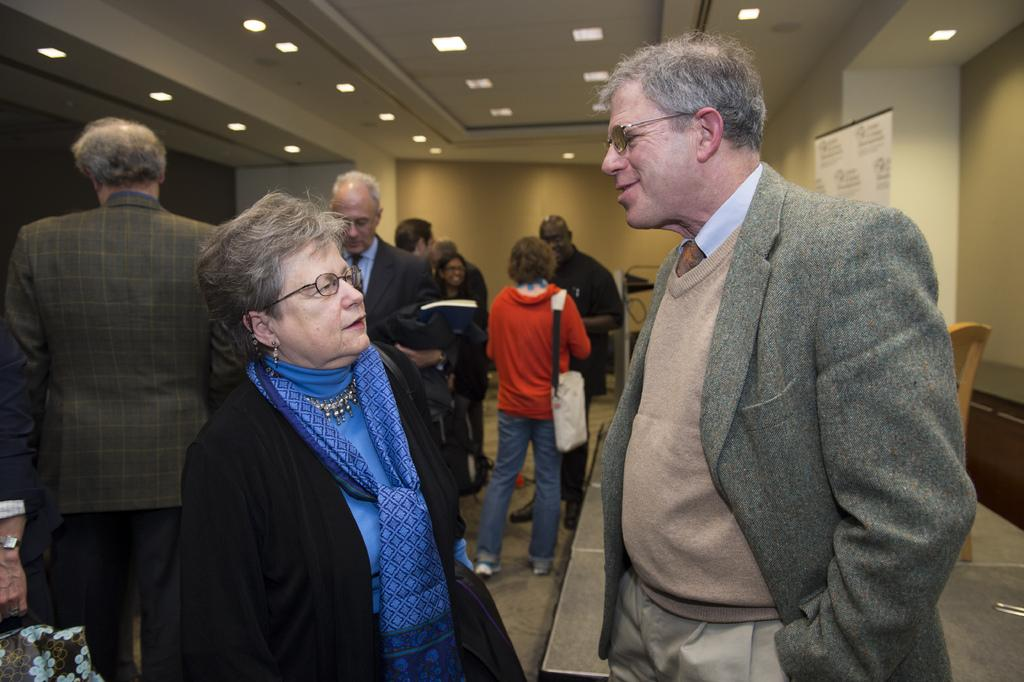What are the people in the image doing? The people in the image are standing on the floor. What can be seen in the background of the image? There is a wall and a banner in the background of the image. What is visible at the top of the image? The ceiling is visible at the top of the image. What type of lighting is present in the image? There are ceiling lights on the ceiling. What type of clam is sitting on the table in the image? There is no clam present in the image, nor is there a table. 